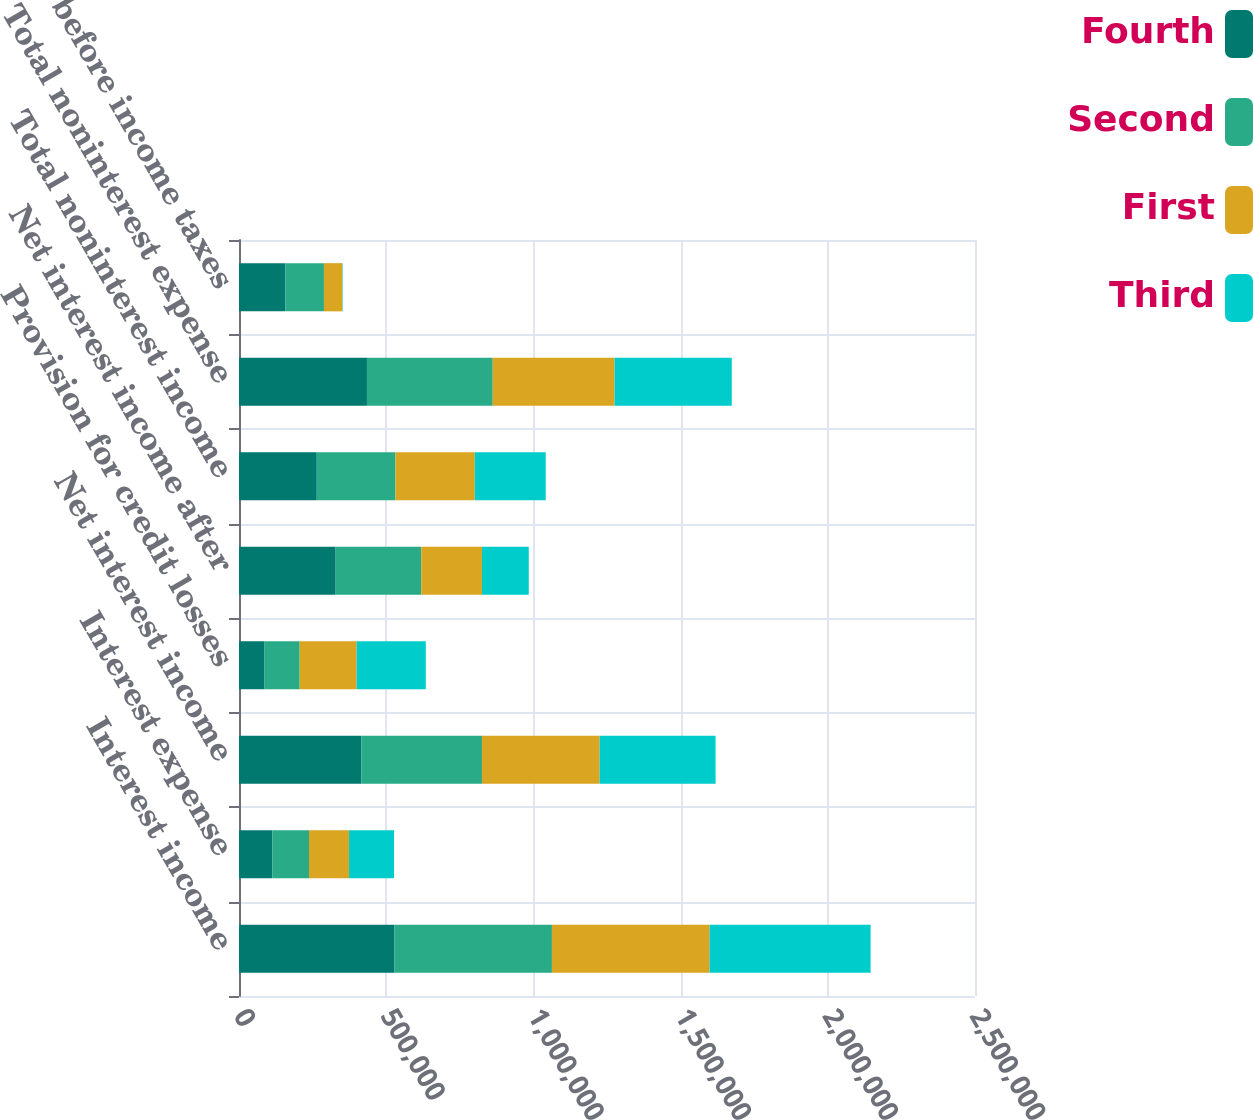Convert chart to OTSL. <chart><loc_0><loc_0><loc_500><loc_500><stacked_bar_chart><ecel><fcel>Interest income<fcel>Interest expense<fcel>Net interest income<fcel>Provision for credit losses<fcel>Net interest income after<fcel>Total noninterest income<fcel>Total noninterest expense<fcel>Income before income taxes<nl><fcel>Fourth<fcel>528291<fcel>112997<fcel>415294<fcel>86973<fcel>328321<fcel>264220<fcel>434593<fcel>157948<nl><fcel>Second<fcel>534669<fcel>124707<fcel>409962<fcel>119160<fcel>290802<fcel>267143<fcel>427309<fcel>130636<nl><fcel>First<fcel>535653<fcel>135997<fcel>399656<fcel>193406<fcel>206250<fcel>269643<fcel>413810<fcel>62083<nl><fcel>Third<fcel>546779<fcel>152886<fcel>393893<fcel>235008<fcel>158885<fcel>240852<fcel>398093<fcel>1644<nl></chart> 